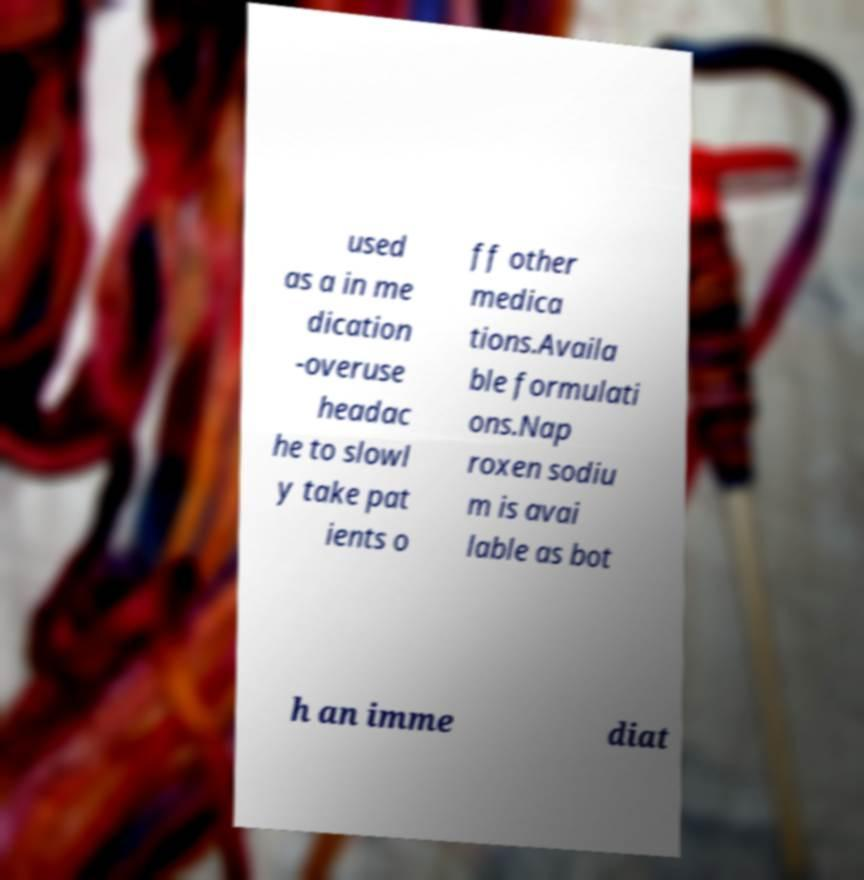Please read and relay the text visible in this image. What does it say? used as a in me dication -overuse headac he to slowl y take pat ients o ff other medica tions.Availa ble formulati ons.Nap roxen sodiu m is avai lable as bot h an imme diat 